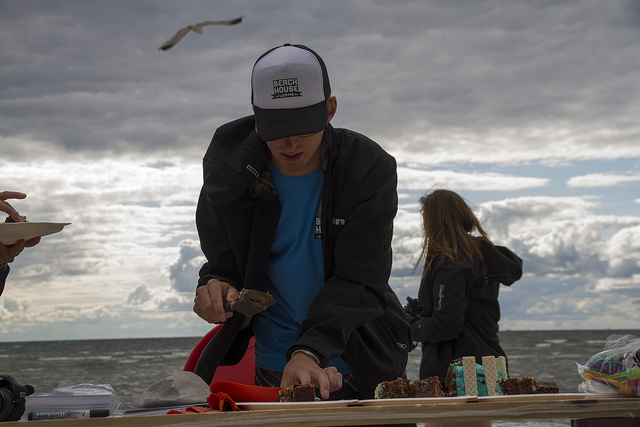How many people are there? 2 